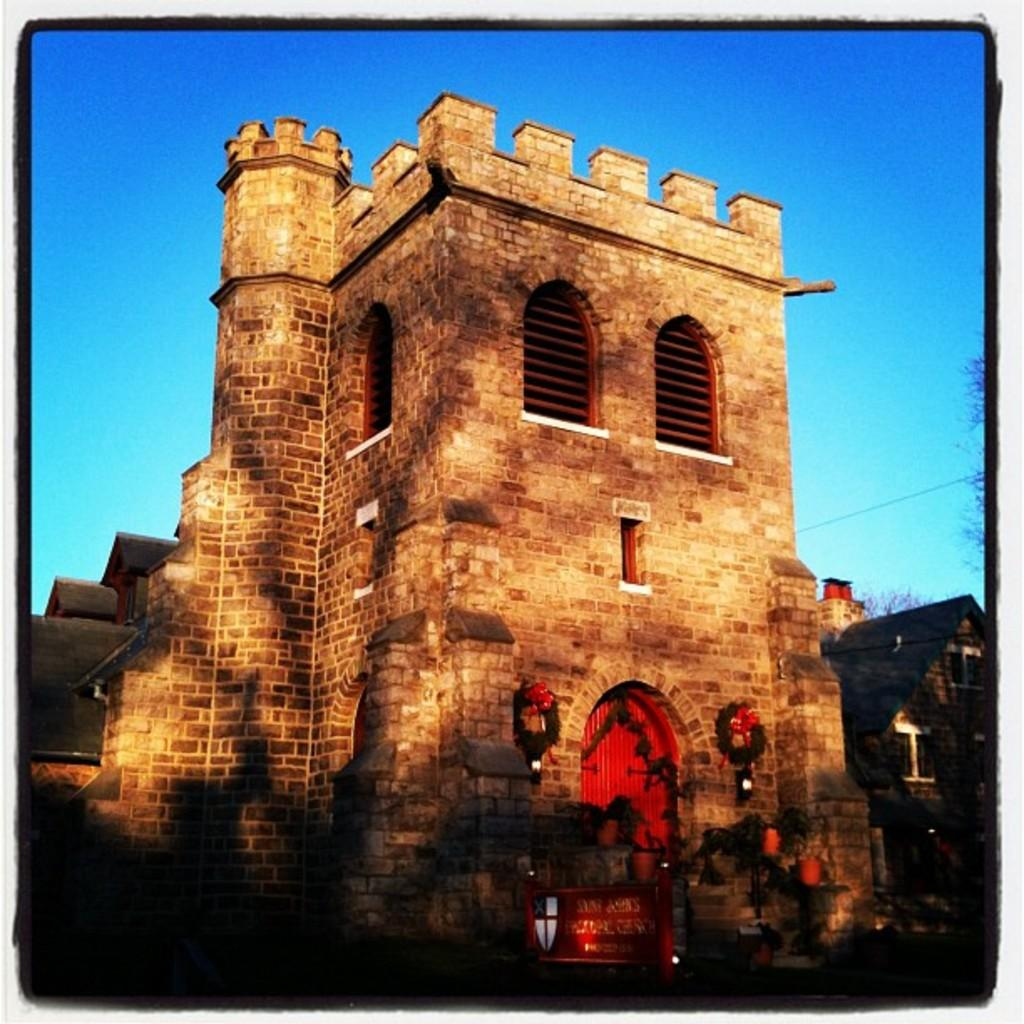What is located in the bottom right side of the image? There is a red door in the bottom right side of the image. What type of structure is in the middle of the image? There is an old building in the middle of the image. What can be seen in the background of the image? The sky is visible in the background of the image. Where is the ice located in the image? There is no ice present in the image. What type of basket can be seen in the image? There is no basket present in the image. 